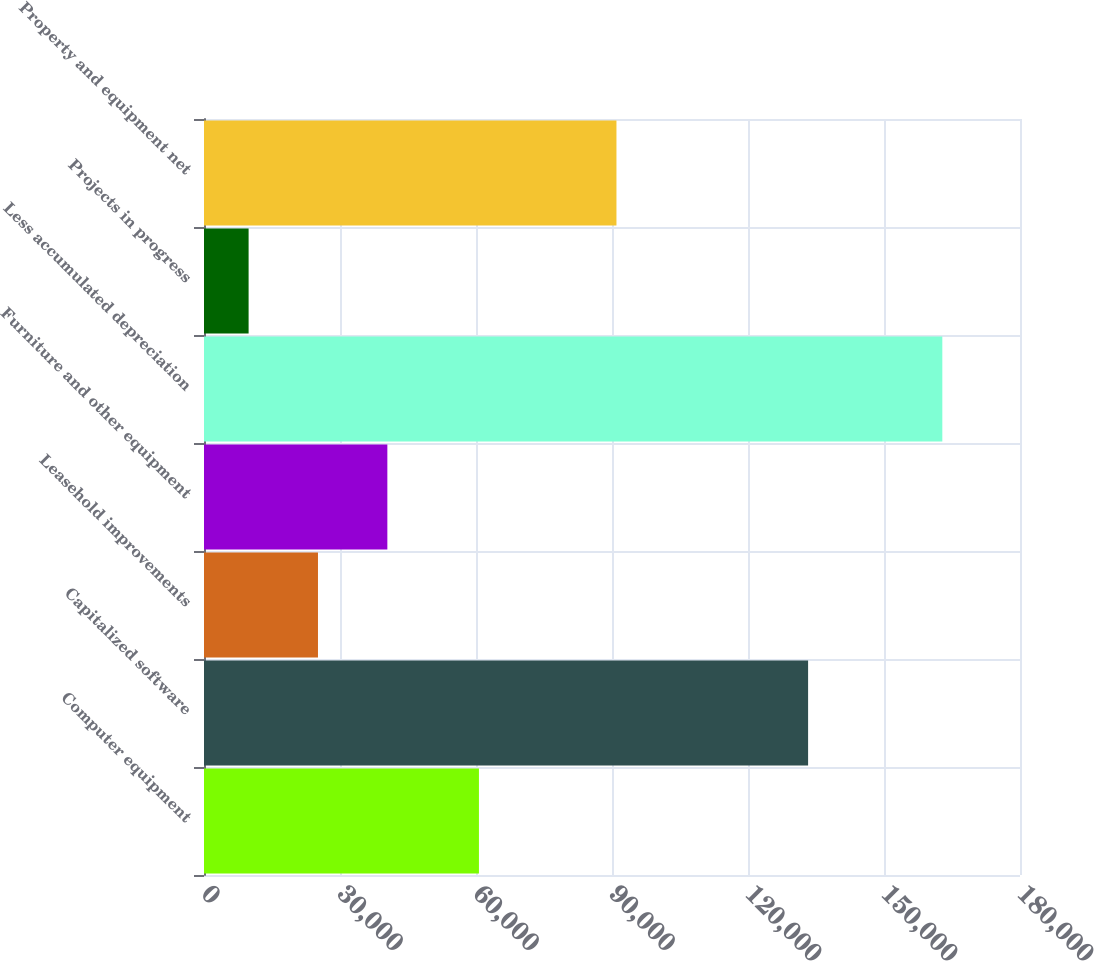<chart> <loc_0><loc_0><loc_500><loc_500><bar_chart><fcel>Computer equipment<fcel>Capitalized software<fcel>Leasehold improvements<fcel>Furniture and other equipment<fcel>Less accumulated depreciation<fcel>Projects in progress<fcel>Property and equipment net<nl><fcel>60648<fcel>133256<fcel>25142.5<fcel>40445<fcel>162865<fcel>9840<fcel>90984<nl></chart> 